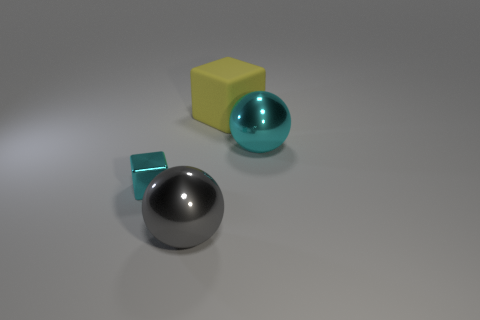Add 3 tiny cyan shiny objects. How many objects exist? 7 Subtract all cyan spheres. Subtract all cyan cubes. How many spheres are left? 1 Subtract all big cyan metallic things. Subtract all gray shiny balls. How many objects are left? 2 Add 4 yellow matte cubes. How many yellow matte cubes are left? 5 Add 3 tiny blue metallic blocks. How many tiny blue metallic blocks exist? 3 Subtract 0 yellow spheres. How many objects are left? 4 